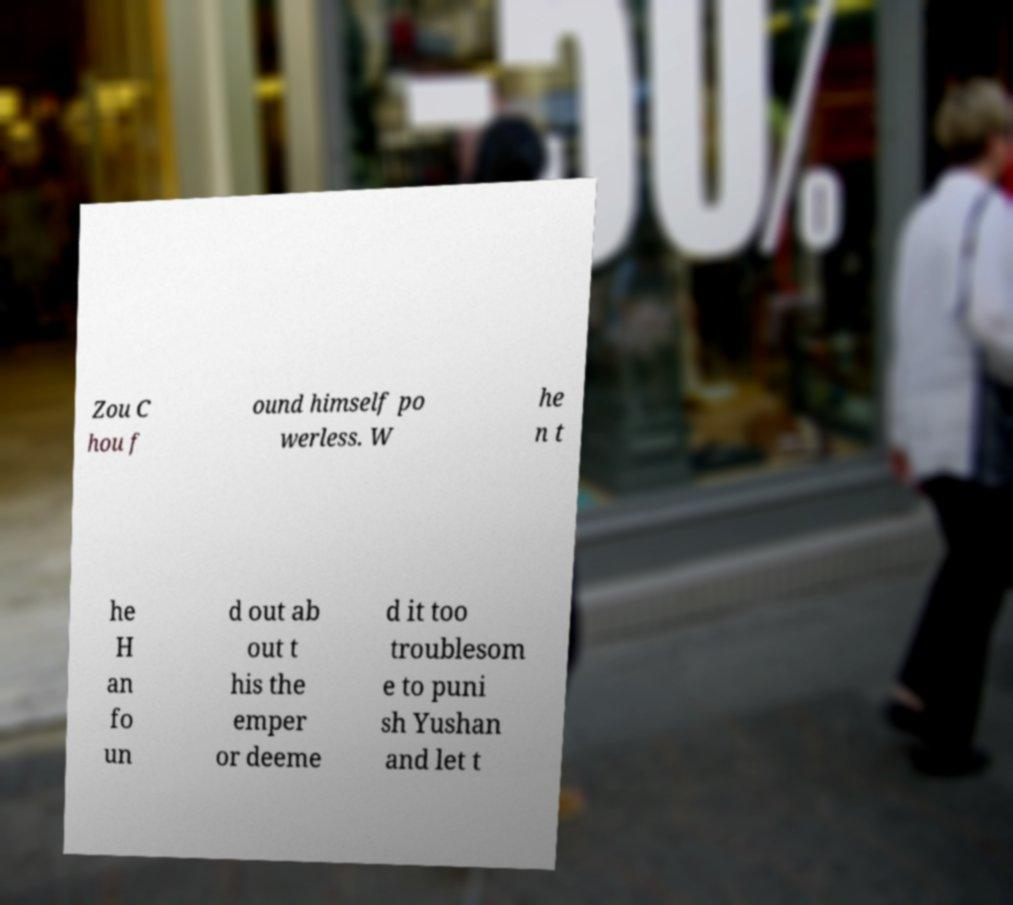I need the written content from this picture converted into text. Can you do that? Zou C hou f ound himself po werless. W he n t he H an fo un d out ab out t his the emper or deeme d it too troublesom e to puni sh Yushan and let t 